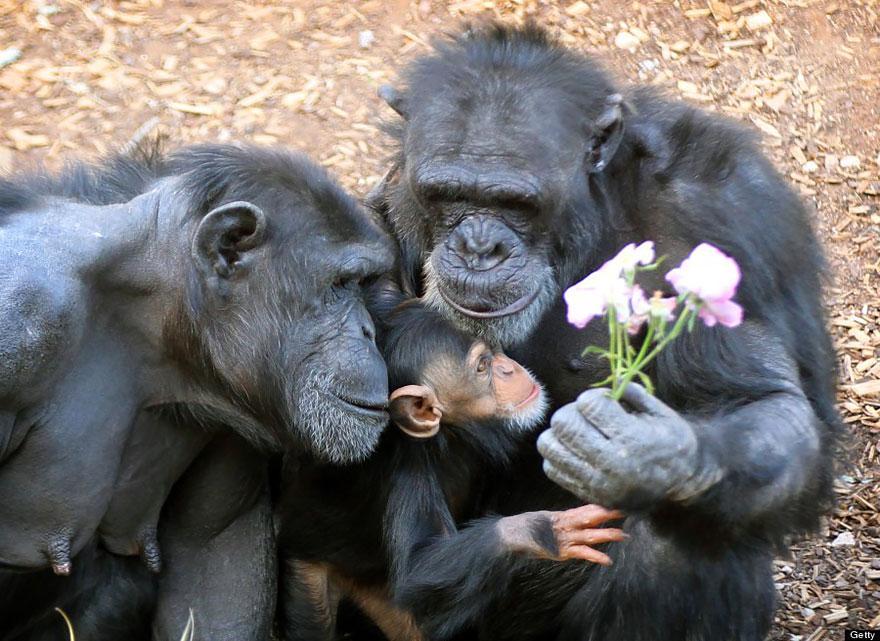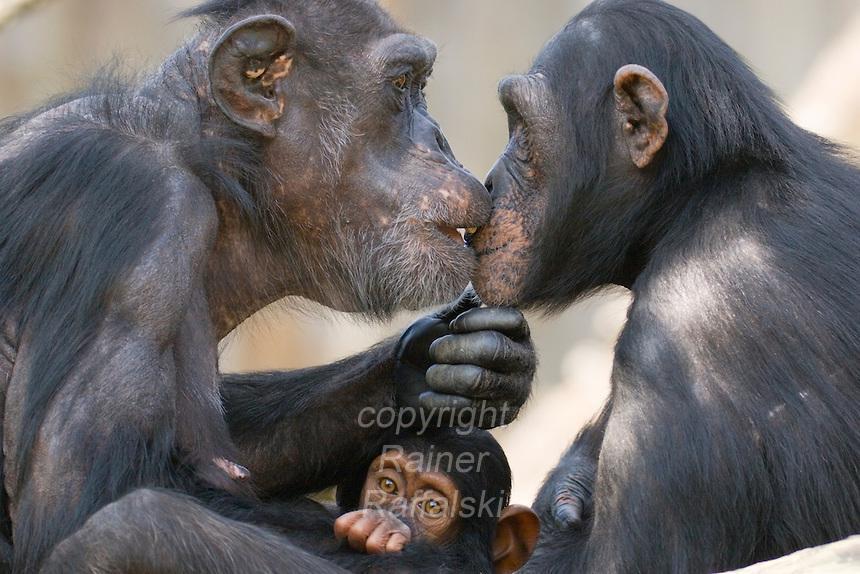The first image is the image on the left, the second image is the image on the right. Considering the images on both sides, is "There are fewer than five chimpanzees in total." valid? Answer yes or no. No. The first image is the image on the left, the second image is the image on the right. Evaluate the accuracy of this statement regarding the images: "Each image includes a baby ape in front of an adult ape.". Is it true? Answer yes or no. Yes. 